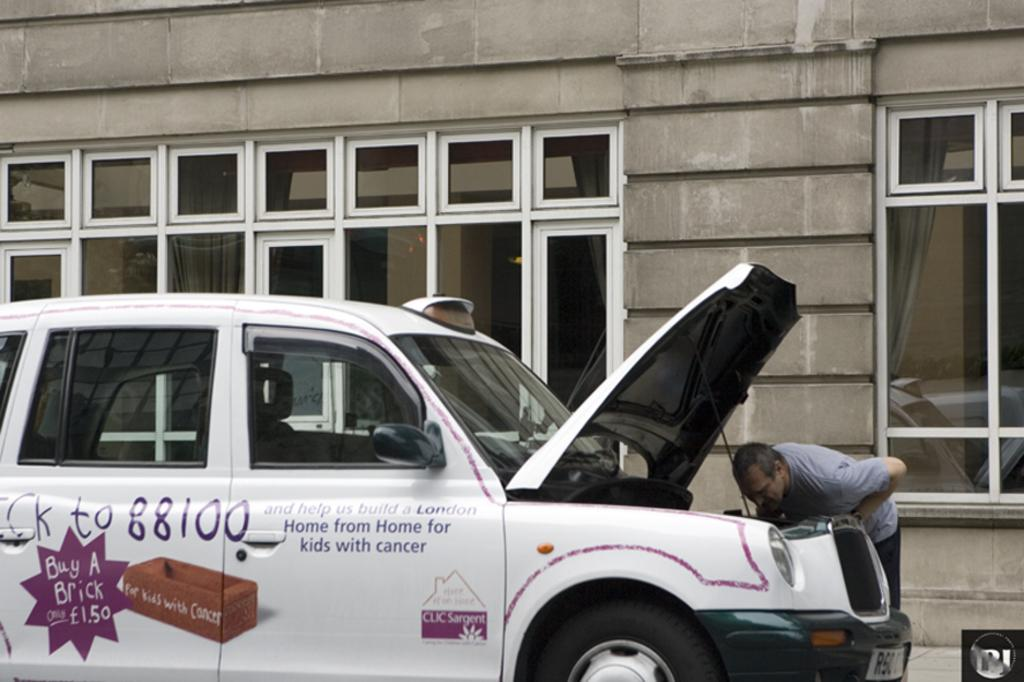<image>
Share a concise interpretation of the image provided. A man leans to look under the hood of a vehicle that has a promotion to buy a brick for cancer victims on its side. 